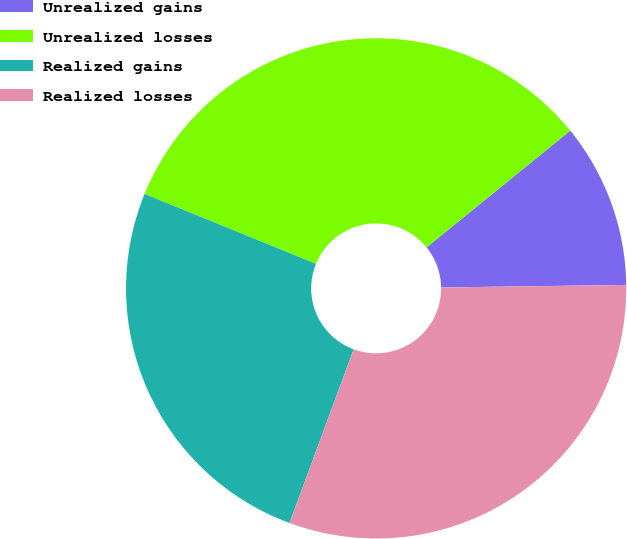<chart> <loc_0><loc_0><loc_500><loc_500><pie_chart><fcel>Unrealized gains<fcel>Unrealized losses<fcel>Realized gains<fcel>Realized losses<nl><fcel>10.64%<fcel>32.98%<fcel>25.53%<fcel>30.85%<nl></chart> 